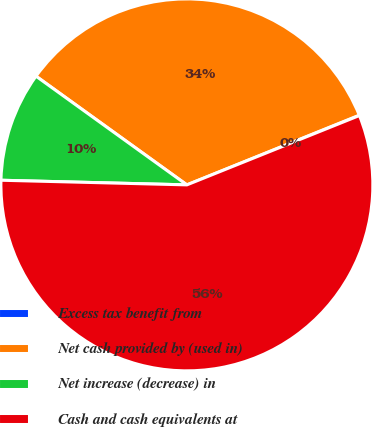Convert chart. <chart><loc_0><loc_0><loc_500><loc_500><pie_chart><fcel>Excess tax benefit from<fcel>Net cash provided by (used in)<fcel>Net increase (decrease) in<fcel>Cash and cash equivalents at<nl><fcel>0.03%<fcel>33.95%<fcel>9.54%<fcel>56.48%<nl></chart> 